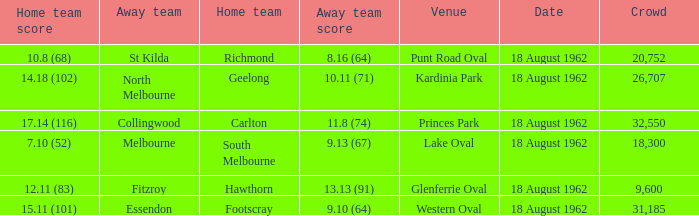What was the away team when the home team scored 10.8 (68)? St Kilda. 